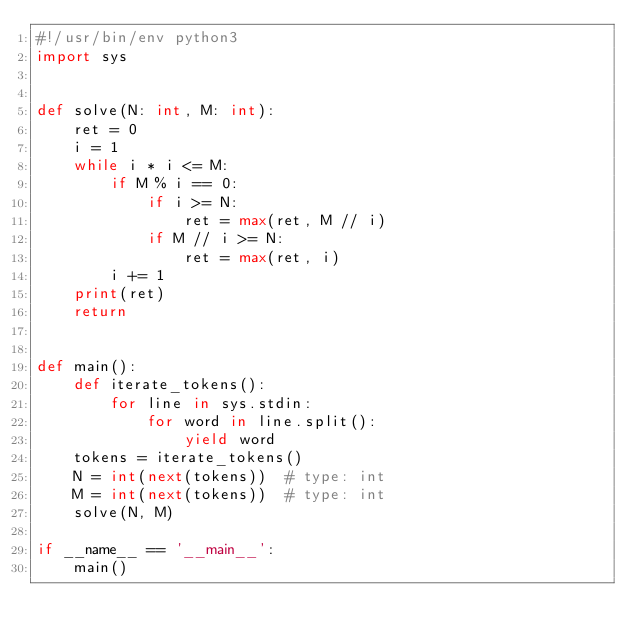<code> <loc_0><loc_0><loc_500><loc_500><_Python_>#!/usr/bin/env python3
import sys


def solve(N: int, M: int):
    ret = 0
    i = 1
    while i * i <= M:
        if M % i == 0:
            if i >= N:
                ret = max(ret, M // i)
            if M // i >= N:
                ret = max(ret, i)
        i += 1
    print(ret)
    return


def main():
    def iterate_tokens():
        for line in sys.stdin:
            for word in line.split():
                yield word
    tokens = iterate_tokens()
    N = int(next(tokens))  # type: int
    M = int(next(tokens))  # type: int
    solve(N, M)

if __name__ == '__main__':
    main()
</code> 